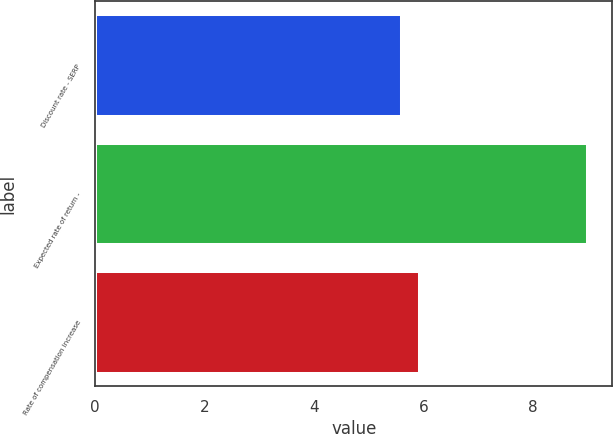Convert chart to OTSL. <chart><loc_0><loc_0><loc_500><loc_500><bar_chart><fcel>Discount rate - SERP<fcel>Expected rate of return -<fcel>Rate of compensation increase<nl><fcel>5.6<fcel>9<fcel>5.94<nl></chart> 